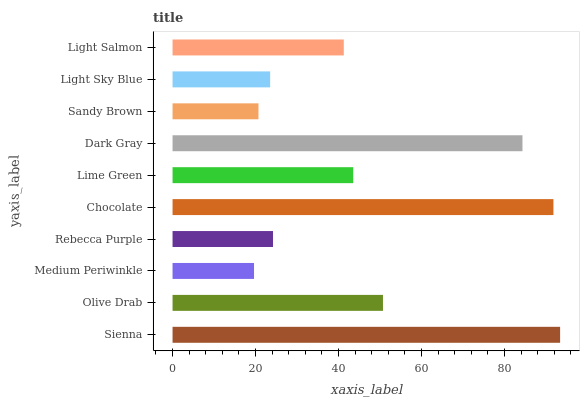Is Medium Periwinkle the minimum?
Answer yes or no. Yes. Is Sienna the maximum?
Answer yes or no. Yes. Is Olive Drab the minimum?
Answer yes or no. No. Is Olive Drab the maximum?
Answer yes or no. No. Is Sienna greater than Olive Drab?
Answer yes or no. Yes. Is Olive Drab less than Sienna?
Answer yes or no. Yes. Is Olive Drab greater than Sienna?
Answer yes or no. No. Is Sienna less than Olive Drab?
Answer yes or no. No. Is Lime Green the high median?
Answer yes or no. Yes. Is Light Salmon the low median?
Answer yes or no. Yes. Is Light Salmon the high median?
Answer yes or no. No. Is Sandy Brown the low median?
Answer yes or no. No. 